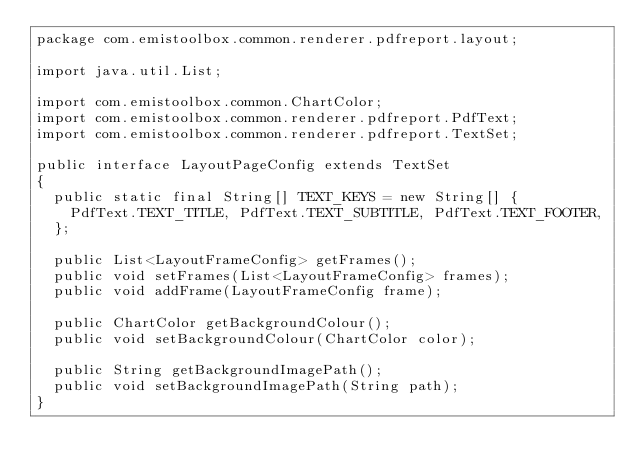<code> <loc_0><loc_0><loc_500><loc_500><_Java_>package com.emistoolbox.common.renderer.pdfreport.layout;

import java.util.List;

import com.emistoolbox.common.ChartColor;
import com.emistoolbox.common.renderer.pdfreport.PdfText;
import com.emistoolbox.common.renderer.pdfreport.TextSet;

public interface LayoutPageConfig extends TextSet
{
	public static final String[] TEXT_KEYS = new String[] { 
		PdfText.TEXT_TITLE, PdfText.TEXT_SUBTITLE, PdfText.TEXT_FOOTER, 
	}; 
	
	public List<LayoutFrameConfig> getFrames(); 
	public void setFrames(List<LayoutFrameConfig> frames); 
	public void addFrame(LayoutFrameConfig frame); 
	
	public ChartColor getBackgroundColour(); 
	public void setBackgroundColour(ChartColor color);

	public String getBackgroundImagePath(); 
	public void setBackgroundImagePath(String path); 
}
</code> 